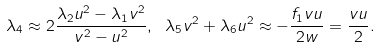<formula> <loc_0><loc_0><loc_500><loc_500>\lambda _ { 4 } \approx 2 \frac { \lambda _ { 2 } u ^ { 2 } - \lambda _ { 1 } v ^ { 2 } } { v ^ { 2 } - u ^ { 2 } } , \ \lambda _ { 5 } v ^ { 2 } + \lambda _ { 6 } u ^ { 2 } \approx - \frac { f _ { 1 } v u } { 2 w } = \frac { v u } { 2 } .</formula> 